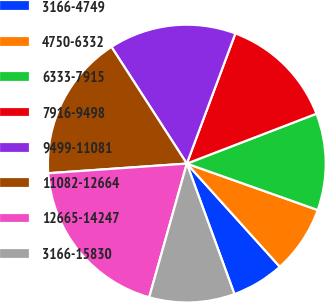<chart> <loc_0><loc_0><loc_500><loc_500><pie_chart><fcel>3166-4749<fcel>4750-6332<fcel>6333-7915<fcel>7916-9498<fcel>9499-11081<fcel>11082-12664<fcel>12665-14247<fcel>3166-15830<nl><fcel>6.11%<fcel>7.9%<fcel>11.27%<fcel>13.47%<fcel>14.81%<fcel>16.98%<fcel>19.53%<fcel>9.93%<nl></chart> 